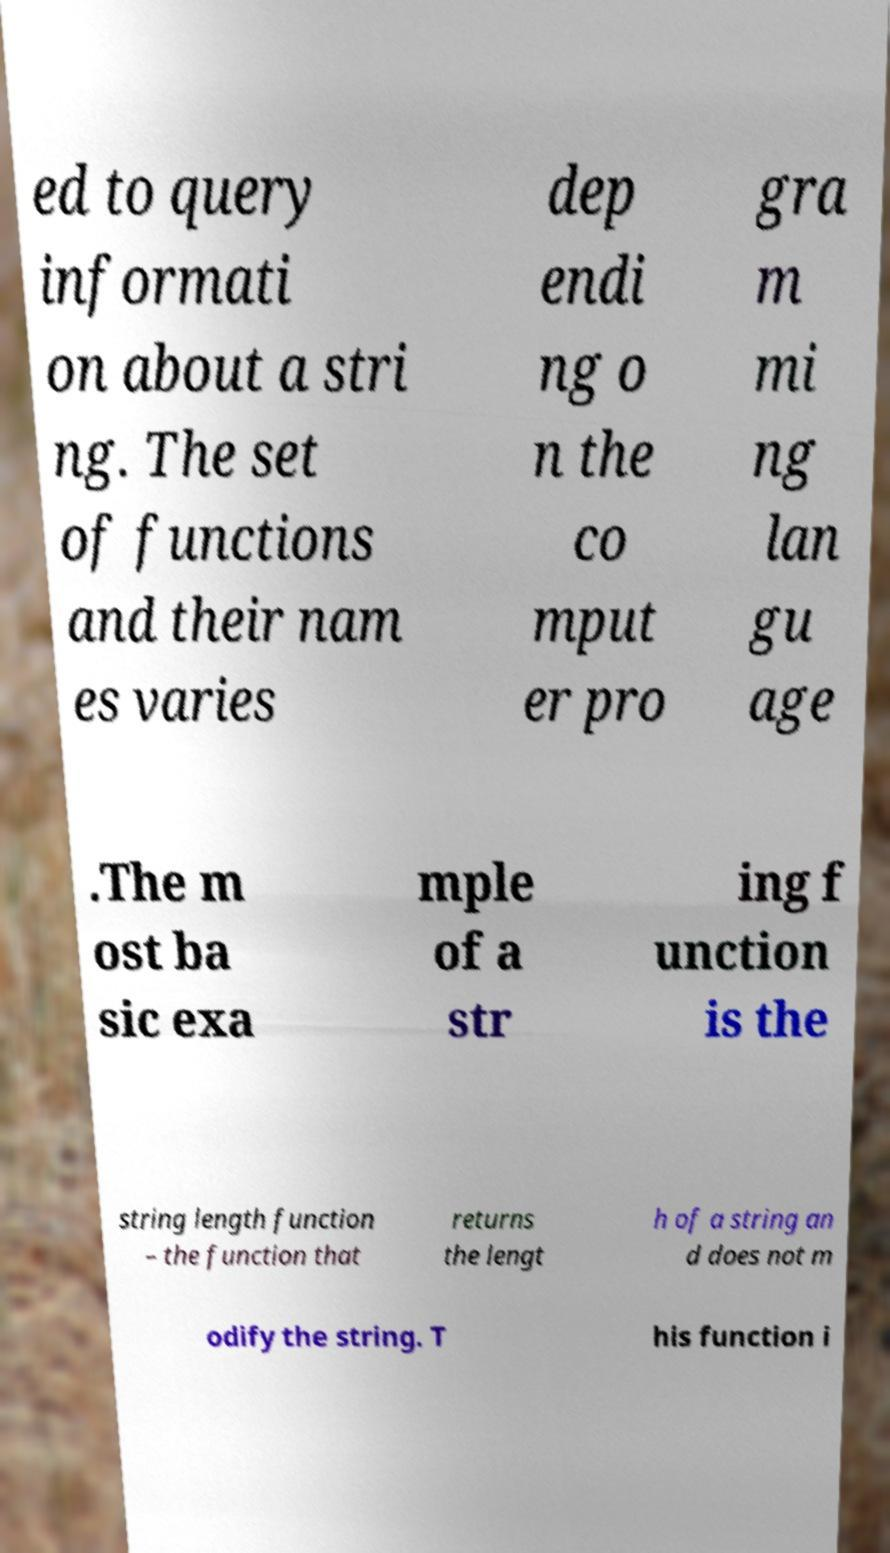For documentation purposes, I need the text within this image transcribed. Could you provide that? ed to query informati on about a stri ng. The set of functions and their nam es varies dep endi ng o n the co mput er pro gra m mi ng lan gu age .The m ost ba sic exa mple of a str ing f unction is the string length function – the function that returns the lengt h of a string an d does not m odify the string. T his function i 